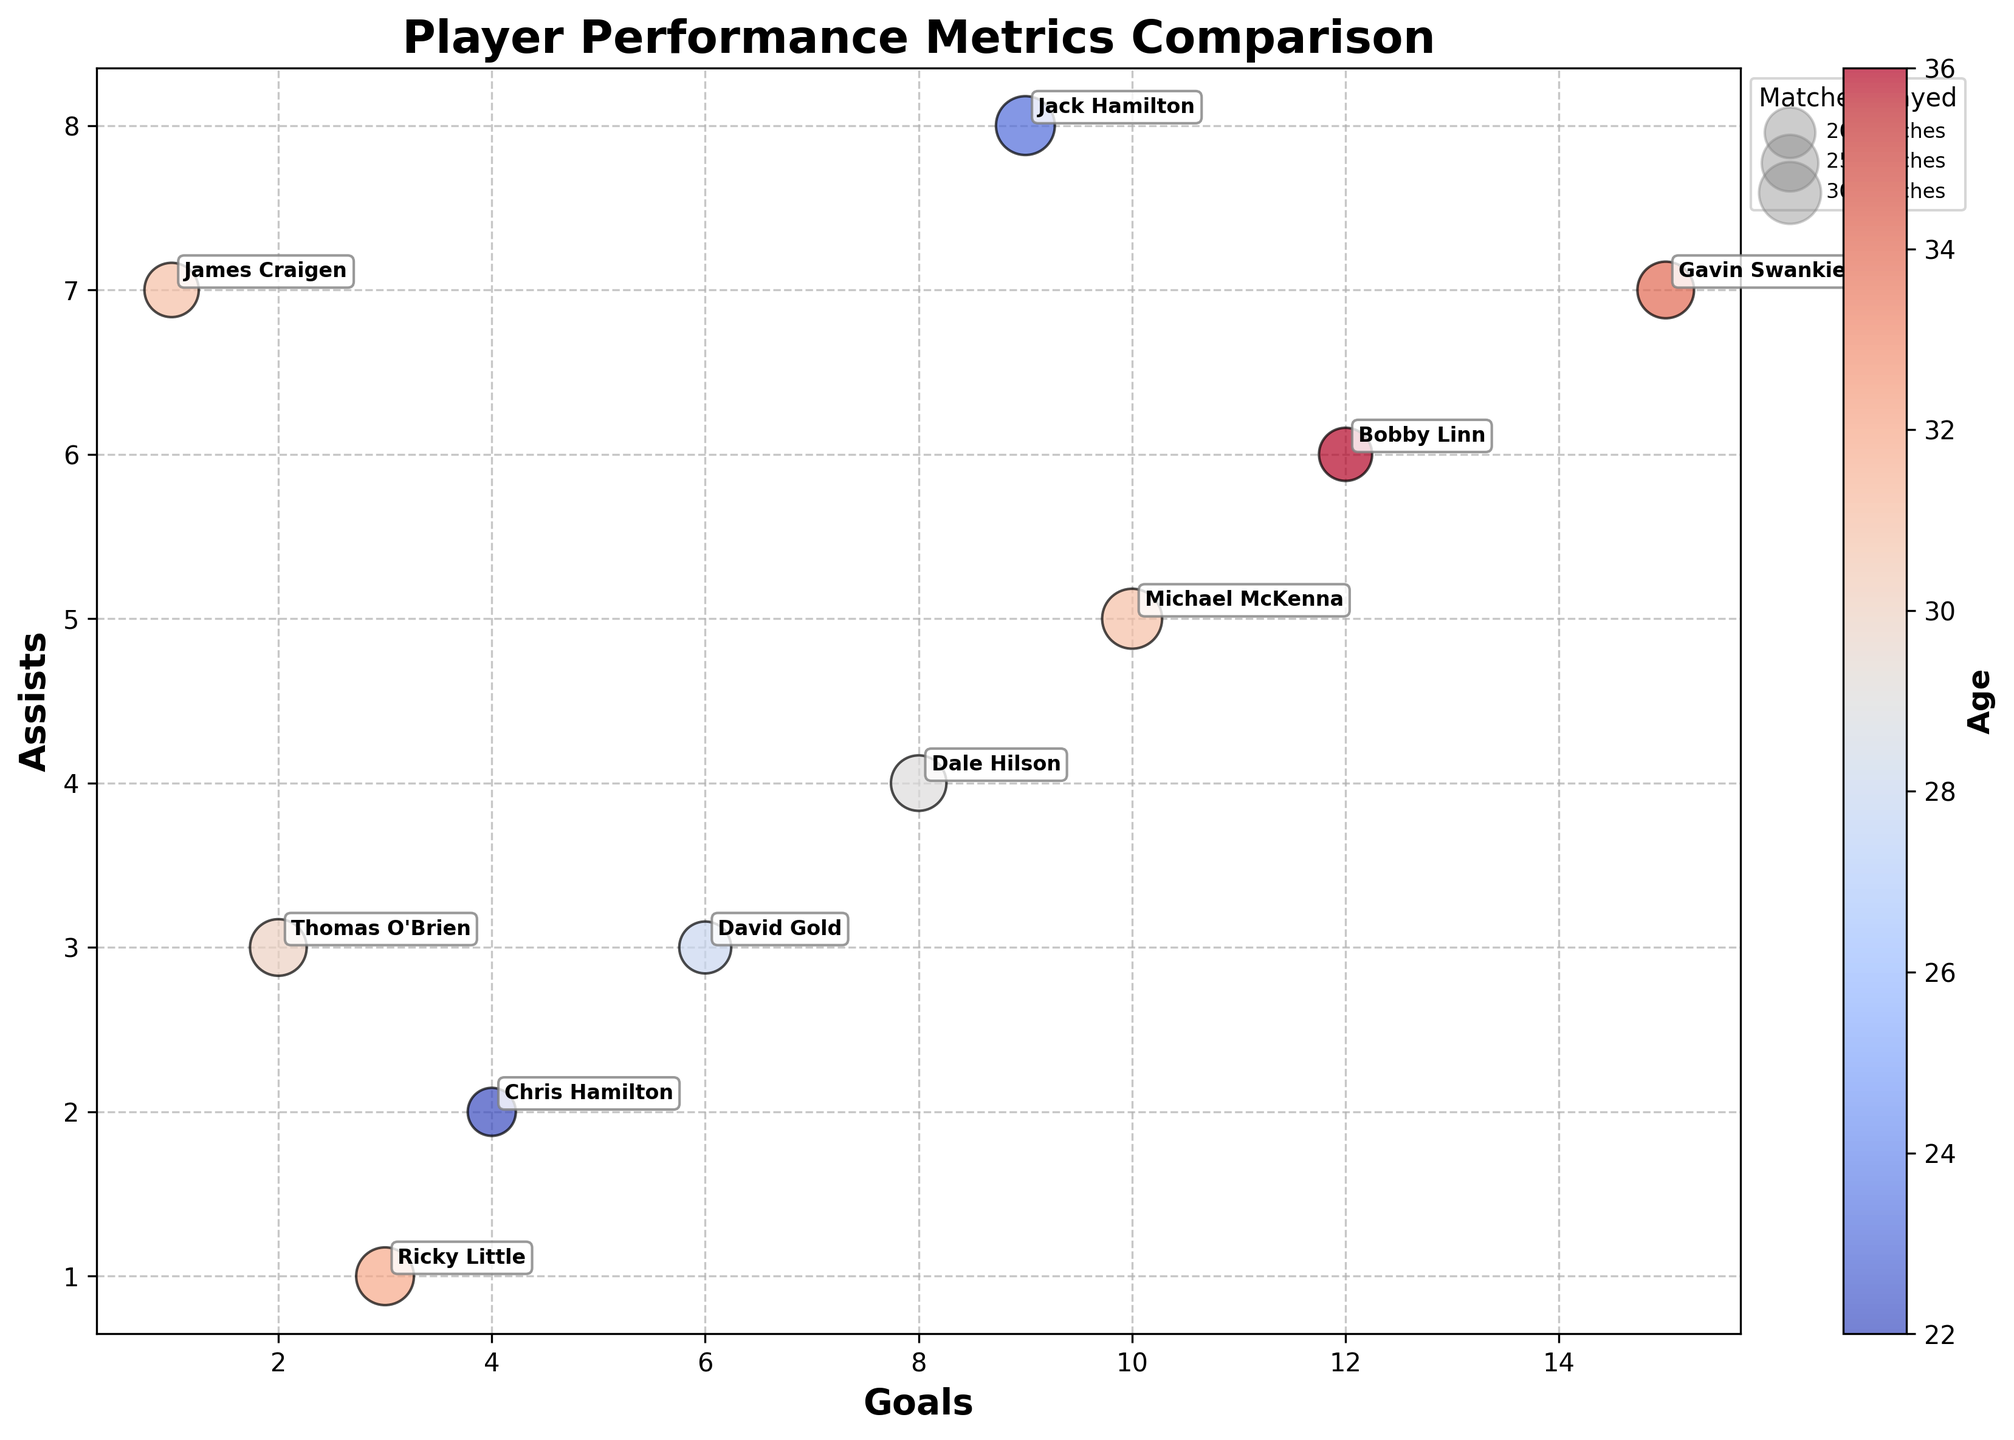How many players are represented in the figure? The chart shows a scatter plot where each player is represented by a separate bubble. By counting the labeled bubbles, we can determine the total number of players.
Answer: 10 Which player has the highest number of goals? By identifying the player whose bubble is positioned furthest to the right on the x-axis (Goals), we can determine the player with the highest number of goals.
Answer: Gavin Swankie Who is the youngest player in the chart? The color bar indicates age, with lighter colors representing younger players. The player with the lightest bubble (leasts dark red) is the youngest.
Answer: Chris Hamilton How many players have more than 10 assists? By examining the vertical position (Assists) and identifying bubbles higher than 10 on the y-axis, we count the number of players that meet the condition.
Answer: 0 Which player has the largest bubble and how many matches did they play? The size of the bubbles corresponds to the number of matches played. The largest bubble represents the player with the most matches.
Answer: Michael McKenna, 28 Which player has the lowest number of assists among those with more than 10 goals? First, identify players with more than 10 goals (x-axis more than 10). Then, check their assist counts (y-axis) and find the lowest among them.
Answer: Bobby Linn What is the average age of players who have scored at least 5 goals? Identify players with at least 5 goals (x-axis ≥ 5) and calculate their age average. Ages of players: 34, 31, 29, 36, 23, 28. Average is (34+31+29+36+23+28)/6.
Answer: 30.2 Compare the number of goals and assists for Jack Hamilton, and state which is higher. Locate Jack Hamilton’s bubble, and check its x-axis (Goals) and y-axis (Assists) positions. Compare the two values.
Answer: Assists are higher (8 assists vs 9 goals) Which two players have an equal number of goals and how many goals do they each have? Look for bubbles aligned vertically on the x-axis with the same Goals value.
Answer: Jack Hamilton and Dale Hilson, 9 goals each Who is the oldest player with the lowest number of assists? Identify the player with the least assists by their y-axis position. Among them, find the highest age value.
Answer: Ricky Little, 32 